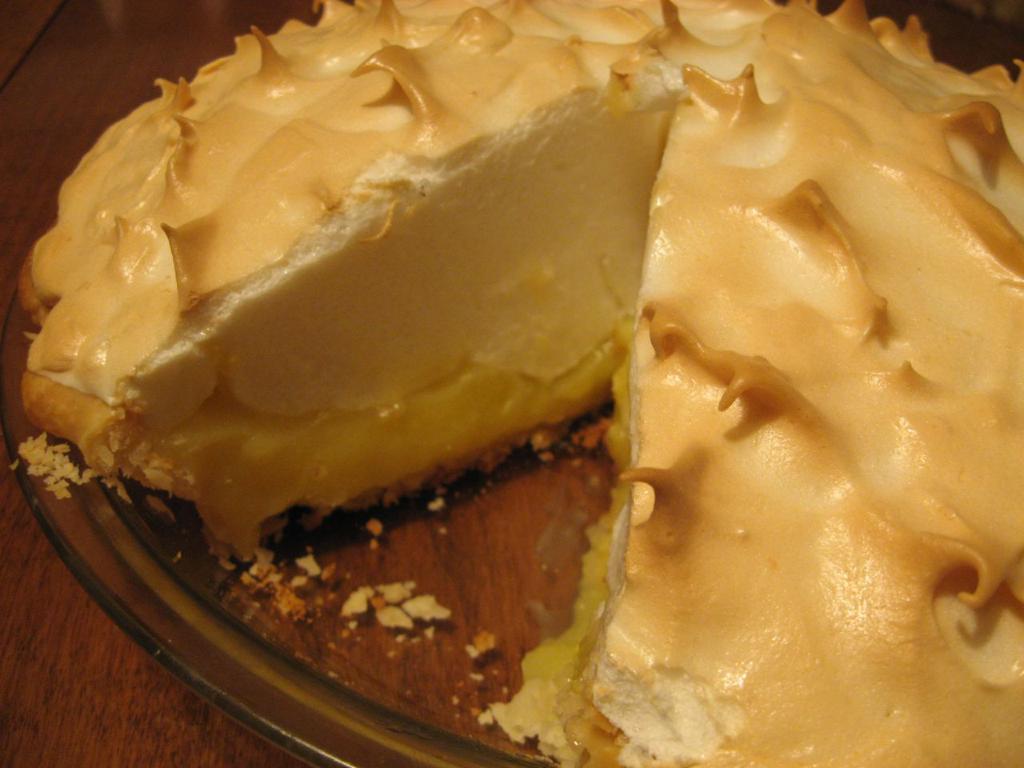In one or two sentences, can you explain what this image depicts? In this picture we can see a glass bowl, there is cheesecake present in this bowl, at the bottom there is wooden surface. 